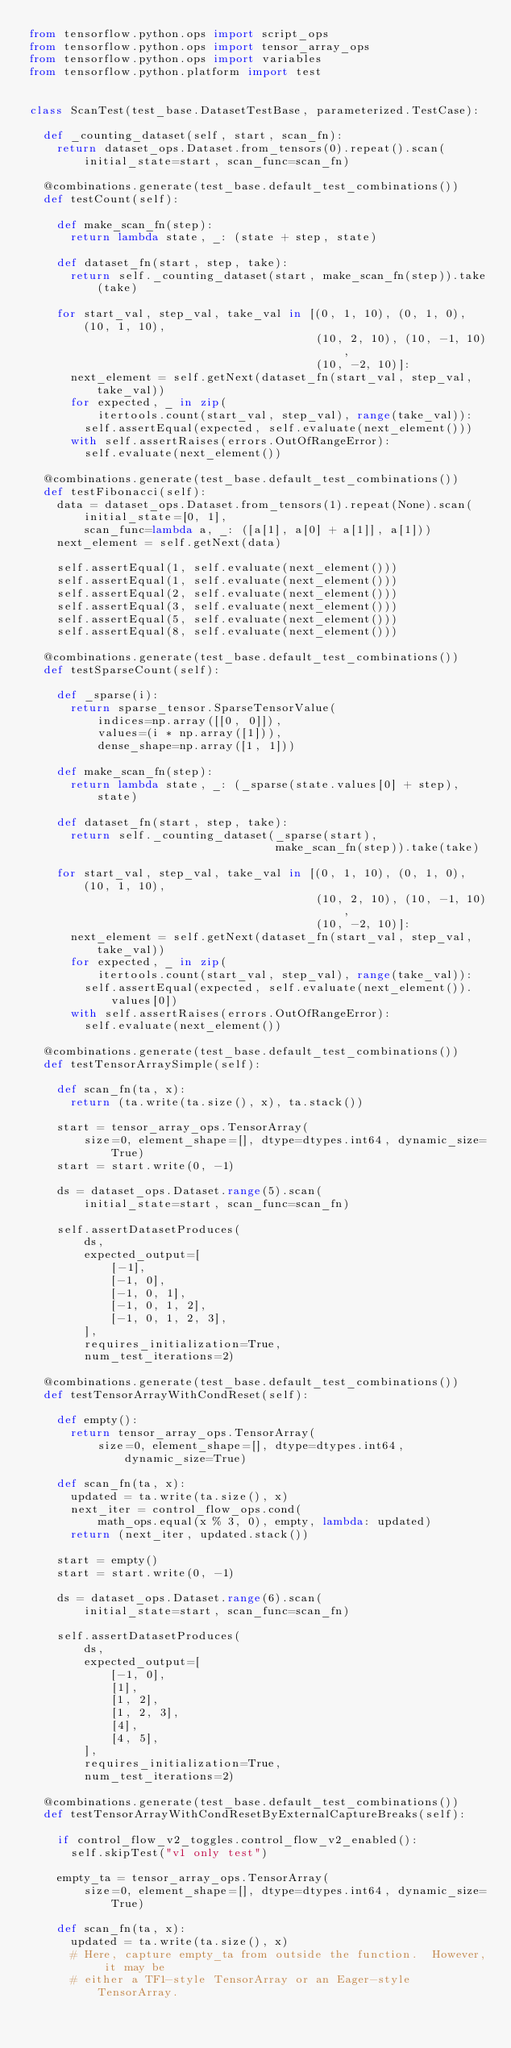Convert code to text. <code><loc_0><loc_0><loc_500><loc_500><_Python_>from tensorflow.python.ops import script_ops
from tensorflow.python.ops import tensor_array_ops
from tensorflow.python.ops import variables
from tensorflow.python.platform import test


class ScanTest(test_base.DatasetTestBase, parameterized.TestCase):

  def _counting_dataset(self, start, scan_fn):
    return dataset_ops.Dataset.from_tensors(0).repeat().scan(
        initial_state=start, scan_func=scan_fn)

  @combinations.generate(test_base.default_test_combinations())
  def testCount(self):

    def make_scan_fn(step):
      return lambda state, _: (state + step, state)

    def dataset_fn(start, step, take):
      return self._counting_dataset(start, make_scan_fn(step)).take(take)

    for start_val, step_val, take_val in [(0, 1, 10), (0, 1, 0), (10, 1, 10),
                                          (10, 2, 10), (10, -1, 10),
                                          (10, -2, 10)]:
      next_element = self.getNext(dataset_fn(start_val, step_val, take_val))
      for expected, _ in zip(
          itertools.count(start_val, step_val), range(take_val)):
        self.assertEqual(expected, self.evaluate(next_element()))
      with self.assertRaises(errors.OutOfRangeError):
        self.evaluate(next_element())

  @combinations.generate(test_base.default_test_combinations())
  def testFibonacci(self):
    data = dataset_ops.Dataset.from_tensors(1).repeat(None).scan(
        initial_state=[0, 1],
        scan_func=lambda a, _: ([a[1], a[0] + a[1]], a[1]))
    next_element = self.getNext(data)

    self.assertEqual(1, self.evaluate(next_element()))
    self.assertEqual(1, self.evaluate(next_element()))
    self.assertEqual(2, self.evaluate(next_element()))
    self.assertEqual(3, self.evaluate(next_element()))
    self.assertEqual(5, self.evaluate(next_element()))
    self.assertEqual(8, self.evaluate(next_element()))

  @combinations.generate(test_base.default_test_combinations())
  def testSparseCount(self):

    def _sparse(i):
      return sparse_tensor.SparseTensorValue(
          indices=np.array([[0, 0]]),
          values=(i * np.array([1])),
          dense_shape=np.array([1, 1]))

    def make_scan_fn(step):
      return lambda state, _: (_sparse(state.values[0] + step), state)

    def dataset_fn(start, step, take):
      return self._counting_dataset(_sparse(start),
                                    make_scan_fn(step)).take(take)

    for start_val, step_val, take_val in [(0, 1, 10), (0, 1, 0), (10, 1, 10),
                                          (10, 2, 10), (10, -1, 10),
                                          (10, -2, 10)]:
      next_element = self.getNext(dataset_fn(start_val, step_val, take_val))
      for expected, _ in zip(
          itertools.count(start_val, step_val), range(take_val)):
        self.assertEqual(expected, self.evaluate(next_element()).values[0])
      with self.assertRaises(errors.OutOfRangeError):
        self.evaluate(next_element())

  @combinations.generate(test_base.default_test_combinations())
  def testTensorArraySimple(self):

    def scan_fn(ta, x):
      return (ta.write(ta.size(), x), ta.stack())

    start = tensor_array_ops.TensorArray(
        size=0, element_shape=[], dtype=dtypes.int64, dynamic_size=True)
    start = start.write(0, -1)

    ds = dataset_ops.Dataset.range(5).scan(
        initial_state=start, scan_func=scan_fn)

    self.assertDatasetProduces(
        ds,
        expected_output=[
            [-1],
            [-1, 0],
            [-1, 0, 1],
            [-1, 0, 1, 2],
            [-1, 0, 1, 2, 3],
        ],
        requires_initialization=True,
        num_test_iterations=2)

  @combinations.generate(test_base.default_test_combinations())
  def testTensorArrayWithCondReset(self):

    def empty():
      return tensor_array_ops.TensorArray(
          size=0, element_shape=[], dtype=dtypes.int64, dynamic_size=True)

    def scan_fn(ta, x):
      updated = ta.write(ta.size(), x)
      next_iter = control_flow_ops.cond(
          math_ops.equal(x % 3, 0), empty, lambda: updated)
      return (next_iter, updated.stack())

    start = empty()
    start = start.write(0, -1)

    ds = dataset_ops.Dataset.range(6).scan(
        initial_state=start, scan_func=scan_fn)

    self.assertDatasetProduces(
        ds,
        expected_output=[
            [-1, 0],
            [1],
            [1, 2],
            [1, 2, 3],
            [4],
            [4, 5],
        ],
        requires_initialization=True,
        num_test_iterations=2)

  @combinations.generate(test_base.default_test_combinations())
  def testTensorArrayWithCondResetByExternalCaptureBreaks(self):

    if control_flow_v2_toggles.control_flow_v2_enabled():
      self.skipTest("v1 only test")

    empty_ta = tensor_array_ops.TensorArray(
        size=0, element_shape=[], dtype=dtypes.int64, dynamic_size=True)

    def scan_fn(ta, x):
      updated = ta.write(ta.size(), x)
      # Here, capture empty_ta from outside the function.  However, it may be
      # either a TF1-style TensorArray or an Eager-style TensorArray.</code> 